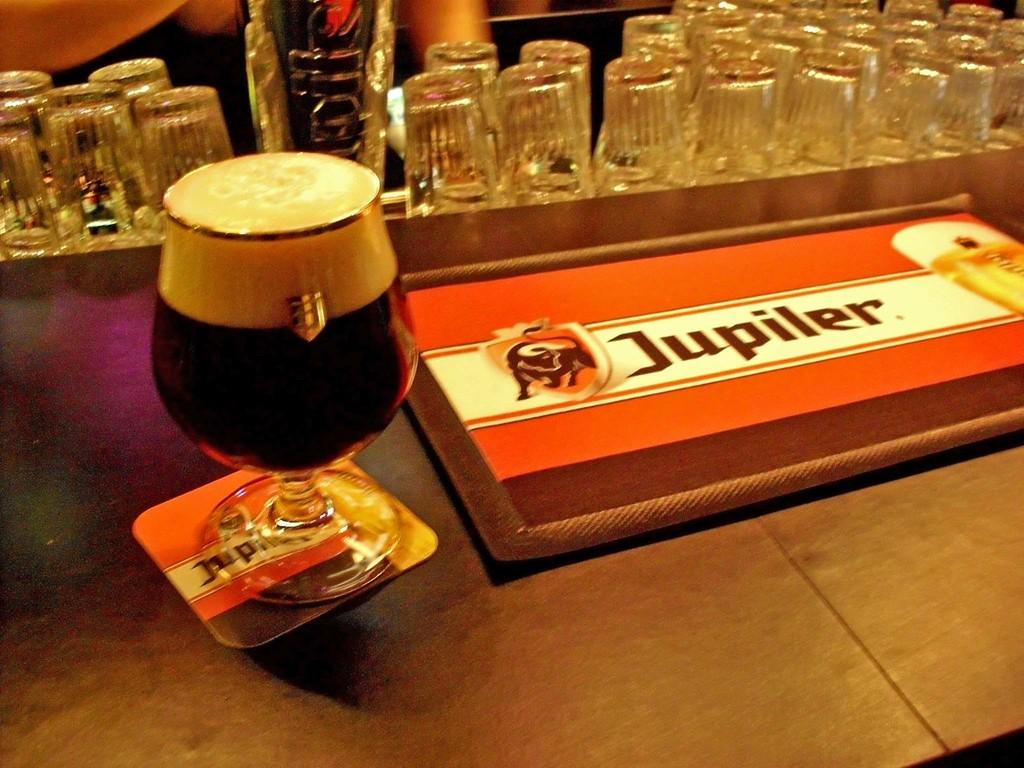<image>
Present a compact description of the photo's key features. A drink on a bar next to a plaque that says Jupiter. 